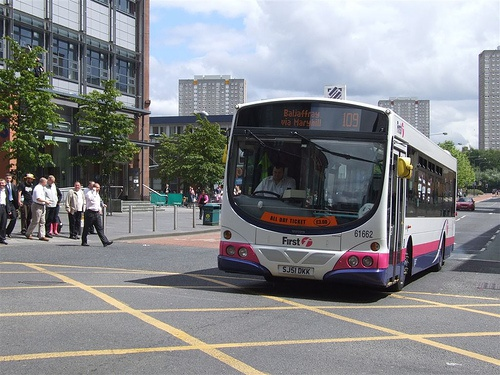Describe the objects in this image and their specific colors. I can see bus in lavender, black, gray, and lightgray tones, people in lavender, black, white, gray, and darkgray tones, people in lavender, gray, white, darkgray, and black tones, people in lavender, black, white, gray, and darkgray tones, and people in lavender, black, gray, and darkblue tones in this image. 